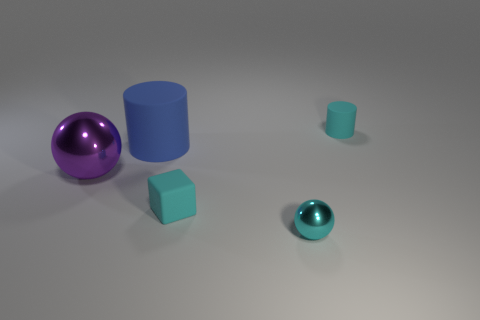Subtract 1 cylinders. How many cylinders are left? 1 Subtract all cylinders. How many objects are left? 3 Subtract all cyan spheres. Subtract all gray cylinders. How many spheres are left? 1 Subtract all cyan cylinders. How many brown balls are left? 0 Subtract all metallic things. Subtract all big objects. How many objects are left? 1 Add 1 cyan metal balls. How many cyan metal balls are left? 2 Add 1 large green metallic objects. How many large green metallic objects exist? 1 Add 2 tiny cyan matte cubes. How many objects exist? 7 Subtract 1 cyan balls. How many objects are left? 4 